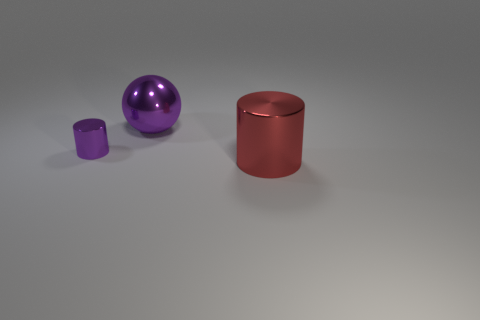Add 1 matte objects. How many objects exist? 4 Add 1 large purple metallic things. How many large purple metallic things exist? 2 Subtract all purple cylinders. How many cylinders are left? 1 Subtract 0 brown spheres. How many objects are left? 3 Subtract all spheres. How many objects are left? 2 Subtract 1 balls. How many balls are left? 0 Subtract all purple cylinders. Subtract all purple blocks. How many cylinders are left? 1 Subtract all blue cylinders. How many brown spheres are left? 0 Subtract all large shiny cylinders. Subtract all red things. How many objects are left? 1 Add 1 large red metal cylinders. How many large red metal cylinders are left? 2 